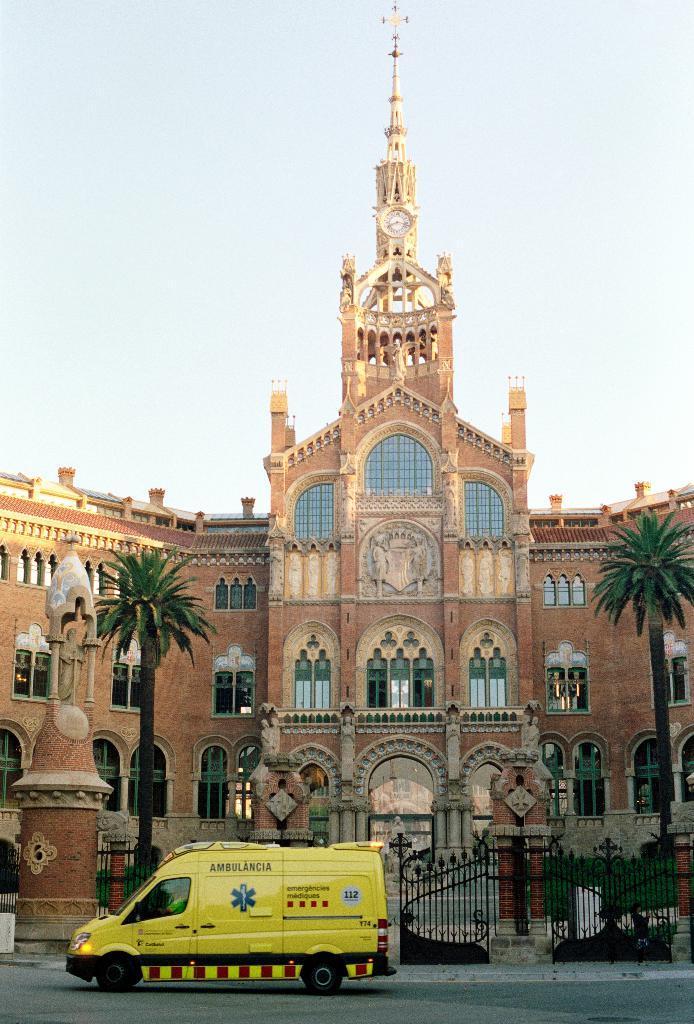In one or two sentences, can you explain what this image depicts? There is a building which has two trees,gate and a vehicle in front of it. 